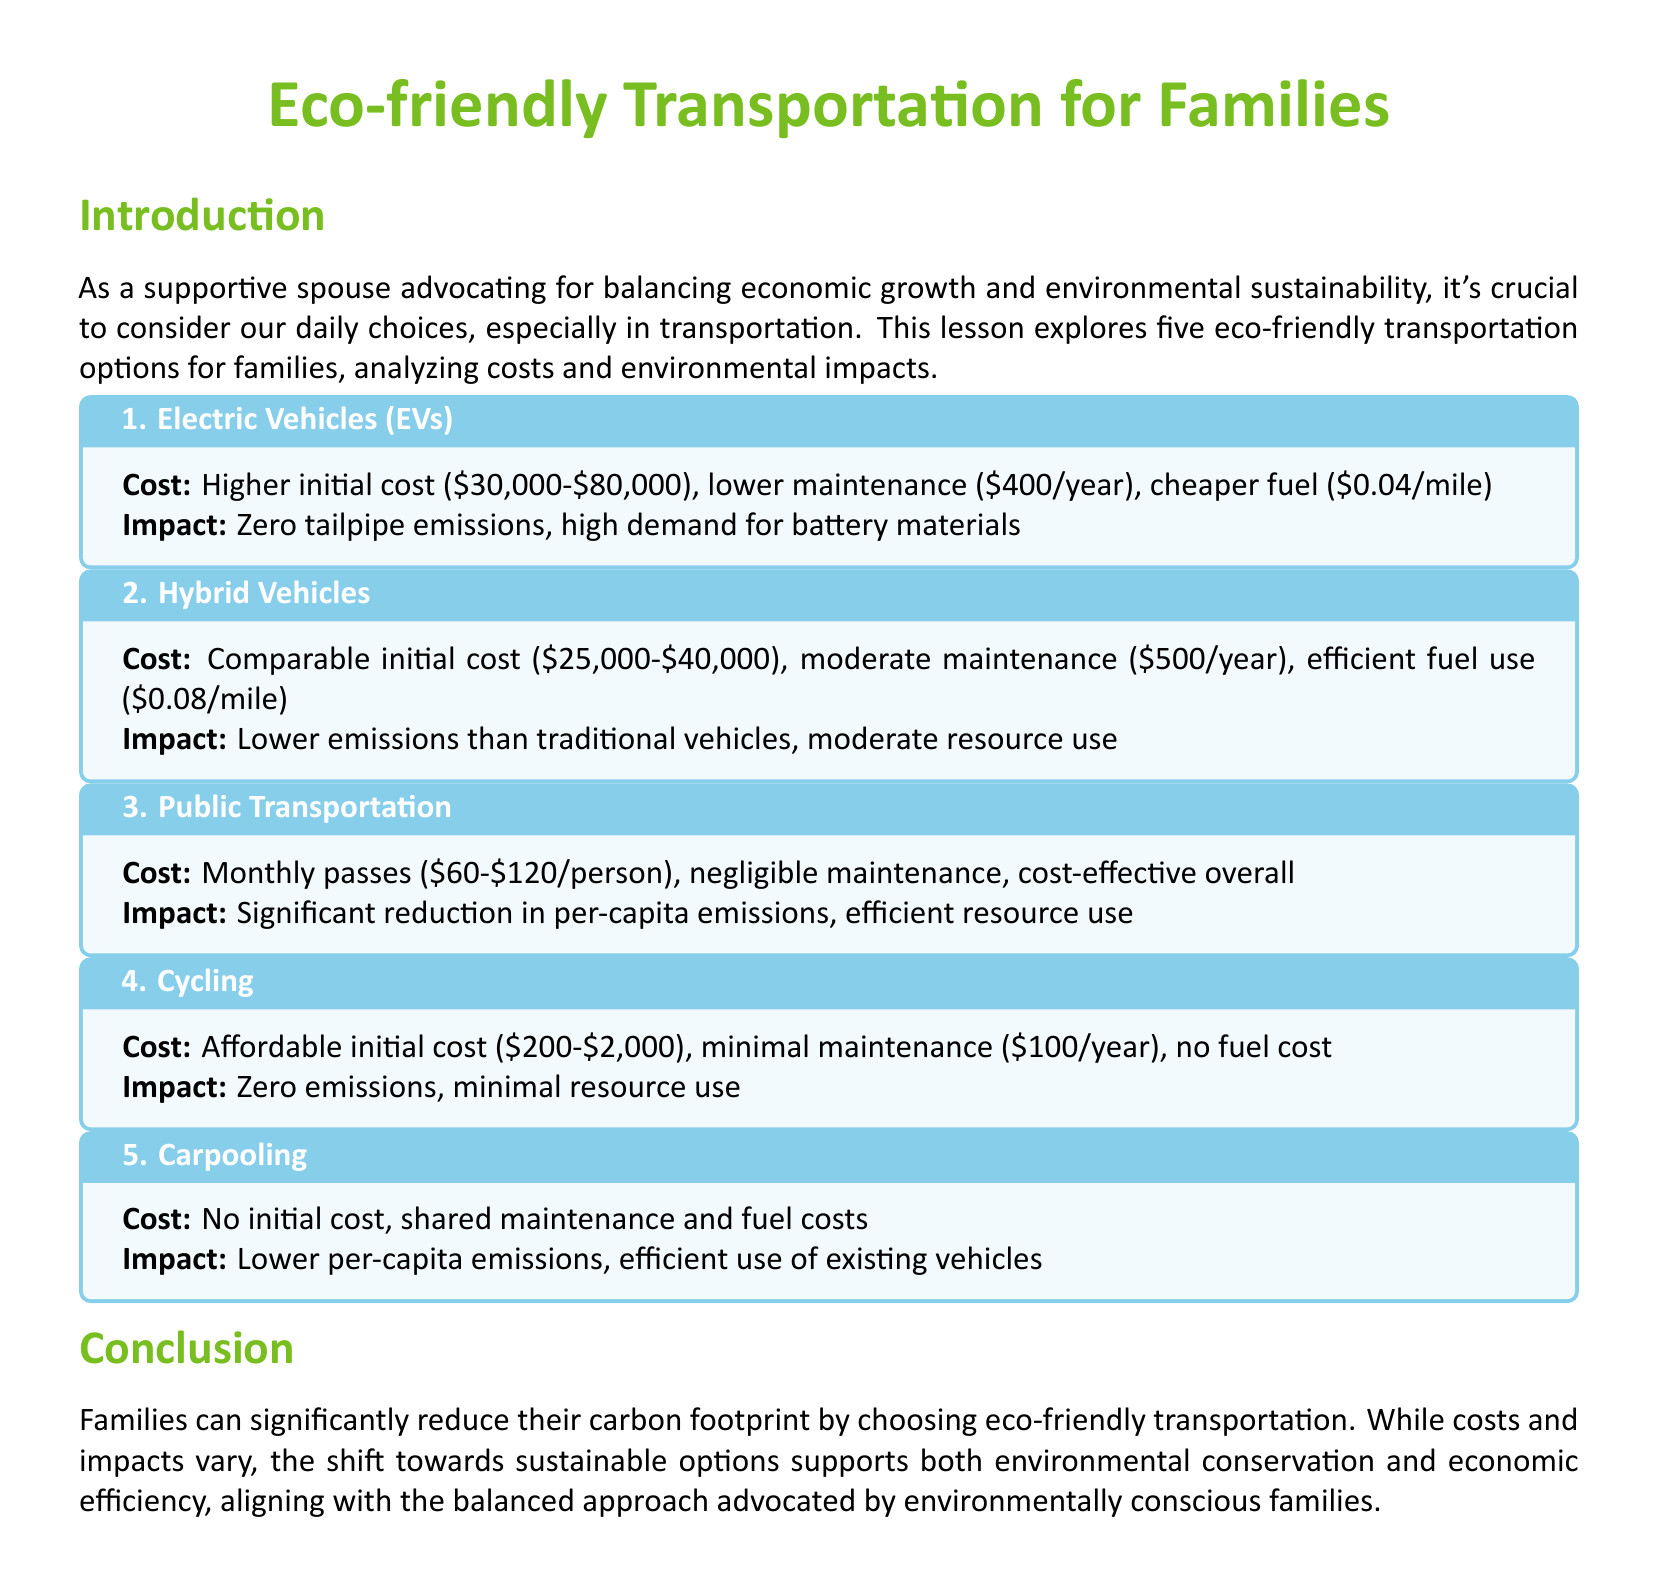What are the initial costs of Electric Vehicles? The initial costs of Electric Vehicles range from $30,000 to $80,000 as stated in the document.
Answer: $30,000-$80,000 What is the maintenance cost of Cycling per year? The document indicates that Cycling has a minimal maintenance cost of $100 per year.
Answer: $100/year What is the environmental impact of Carpooling? The document states that Carpooling has lower per-capita emissions and efficient use of existing vehicles.
Answer: Lower per-capita emissions What is the monthly pass cost range for Public Transportation? The document provides a monthly pass cost range of $60 to $120 per person for Public Transportation.
Answer: $60-$120/person Which eco-friendly option has zero tailpipe emissions? The document lists Electric Vehicles as an option with zero tailpipe emissions.
Answer: Electric Vehicles What is the fuel cost per mile for Hybrid Vehicles? The document states that the fuel cost for Hybrid Vehicles is $0.08 per mile.
Answer: $0.08/mile How does the cost of Cycling compare to other options? The document describes Cycling as having an affordable initial cost ranging from $200 to $2,000, indicating lower financial barriers compared to other options.
Answer: Affordable initial cost Which option displays "zero emissions" in its impact? The document specifically mentions Zero emissions under the impact of Cycling.
Answer: Cycling 